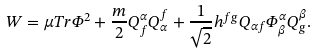<formula> <loc_0><loc_0><loc_500><loc_500>W = \mu T r \Phi ^ { 2 } + \frac { m } { 2 } Q _ { f } ^ { \alpha } Q _ { \alpha } ^ { f } + \frac { 1 } { \sqrt { 2 } } h ^ { f g } Q _ { \alpha f } \Phi _ { \beta } ^ { \alpha } Q _ { g } ^ { \beta } .</formula> 